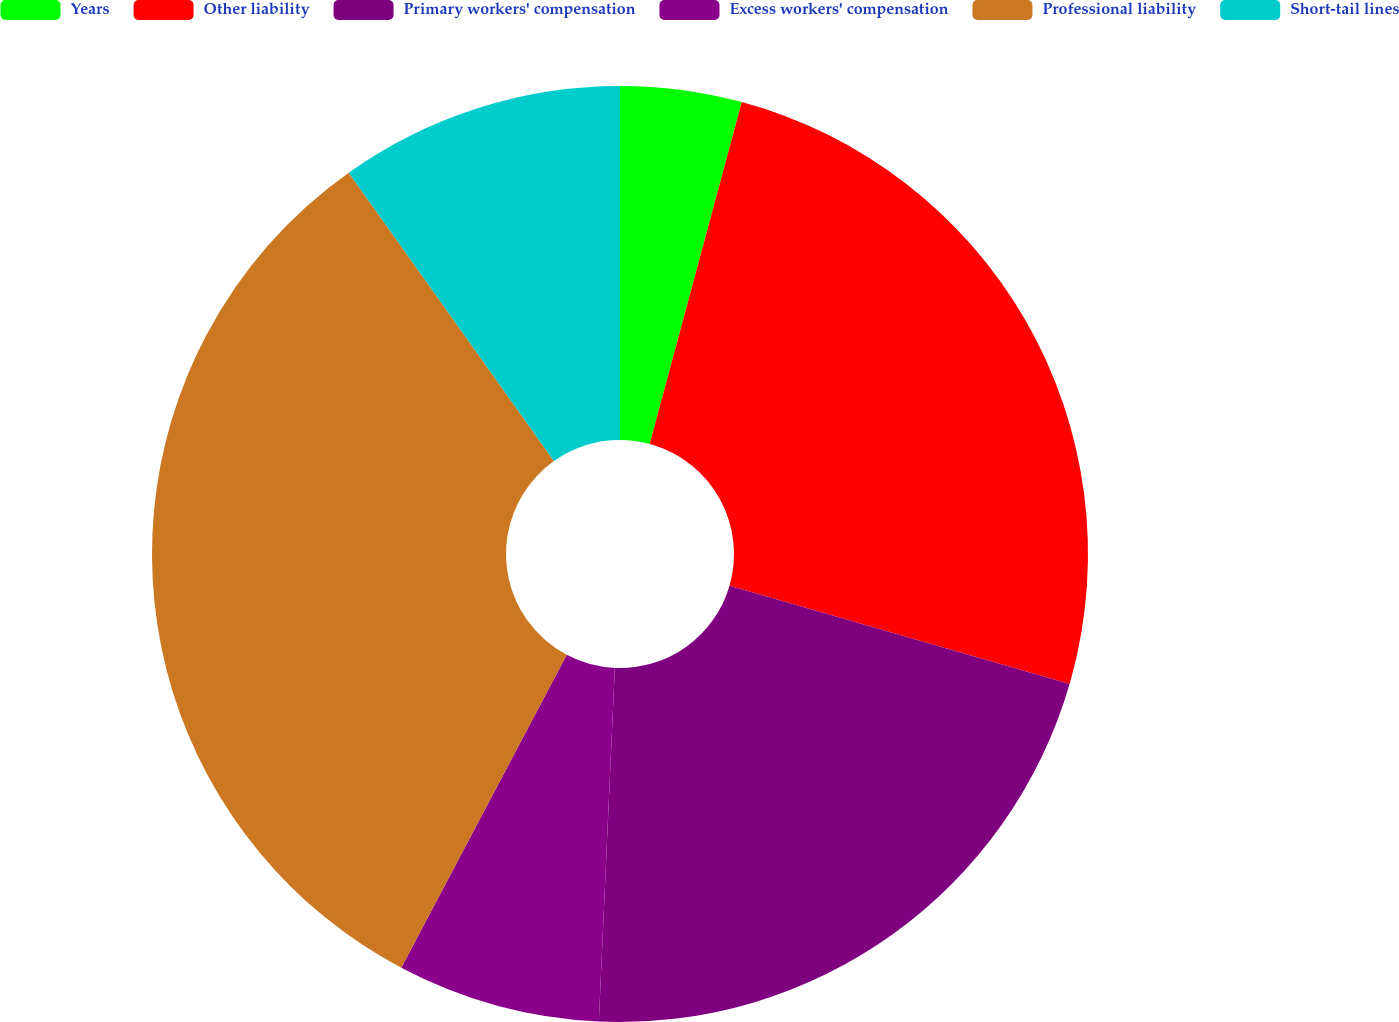<chart> <loc_0><loc_0><loc_500><loc_500><pie_chart><fcel>Years<fcel>Other liability<fcel>Primary workers' compensation<fcel>Excess workers' compensation<fcel>Professional liability<fcel>Short-tail lines<nl><fcel>4.19%<fcel>25.29%<fcel>21.24%<fcel>7.02%<fcel>32.42%<fcel>9.84%<nl></chart> 